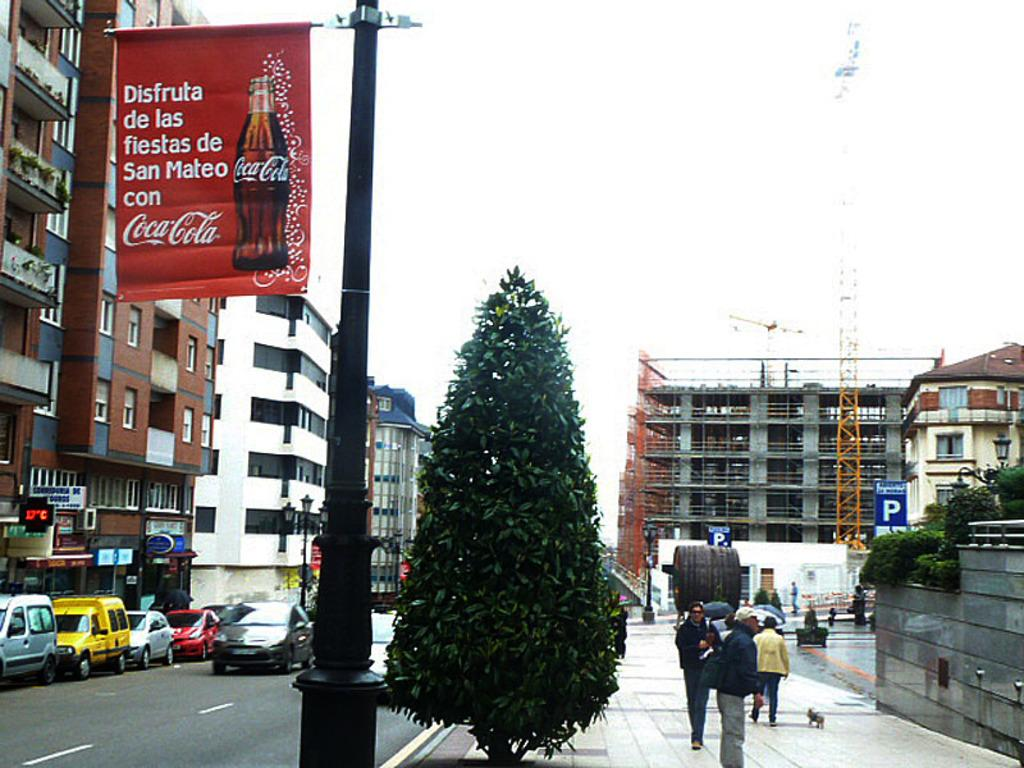<image>
Write a terse but informative summary of the picture. A street in a foreign country that has a banner advertising CocaCola on it. 